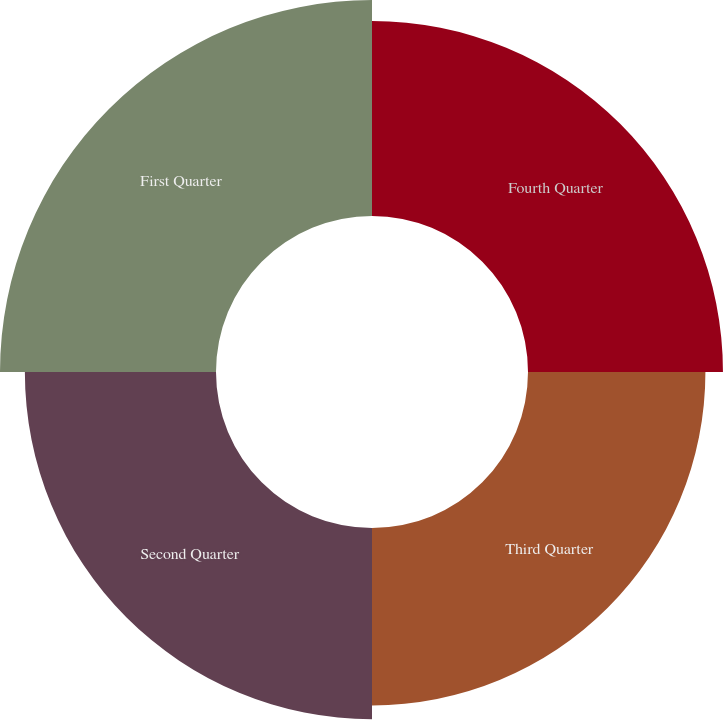Convert chart to OTSL. <chart><loc_0><loc_0><loc_500><loc_500><pie_chart><fcel>Fourth Quarter<fcel>Third Quarter<fcel>Second Quarter<fcel>First Quarter<nl><fcel>25.01%<fcel>22.76%<fcel>24.52%<fcel>27.71%<nl></chart> 